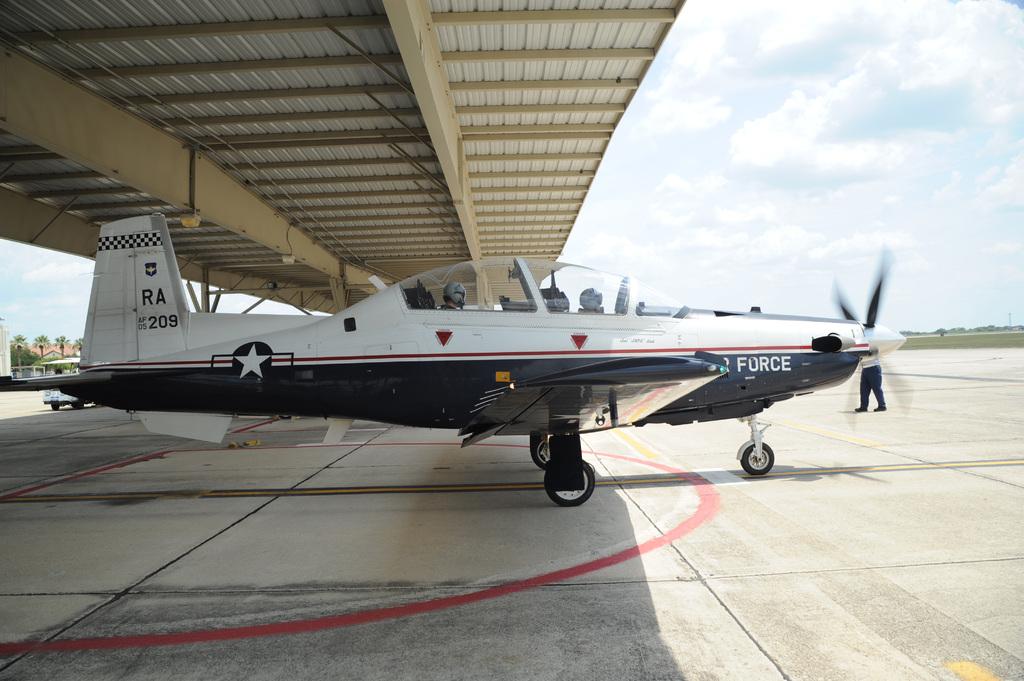What armed forces is this plane?
Your response must be concise. Air force. 